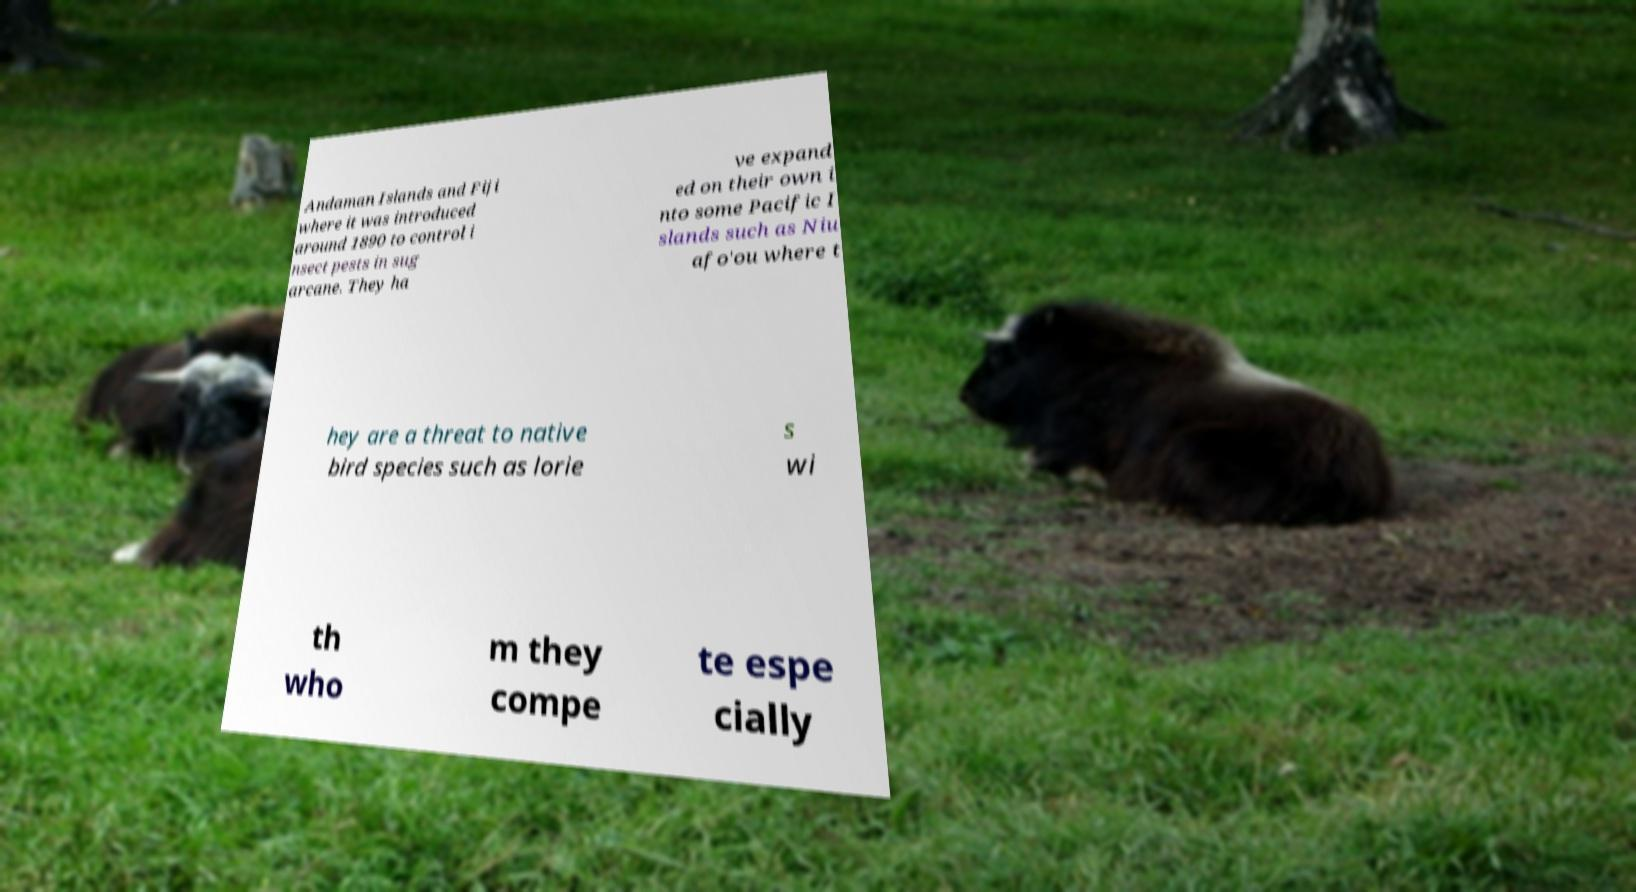Could you extract and type out the text from this image? Andaman Islands and Fiji where it was introduced around 1890 to control i nsect pests in sug arcane. They ha ve expand ed on their own i nto some Pacific I slands such as Niu afo'ou where t hey are a threat to native bird species such as lorie s wi th who m they compe te espe cially 